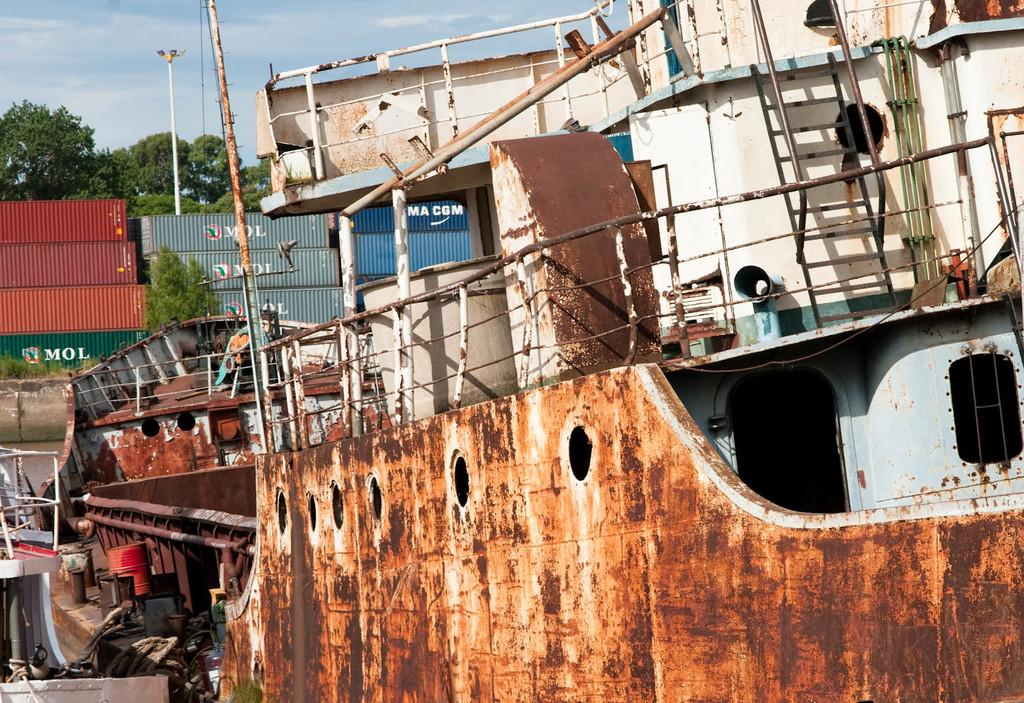<image>
Give a short and clear explanation of the subsequent image. A white, rusty boat in dry dock with shipping containers labeled "MOL" and "MA CGM" stacked behind it. 